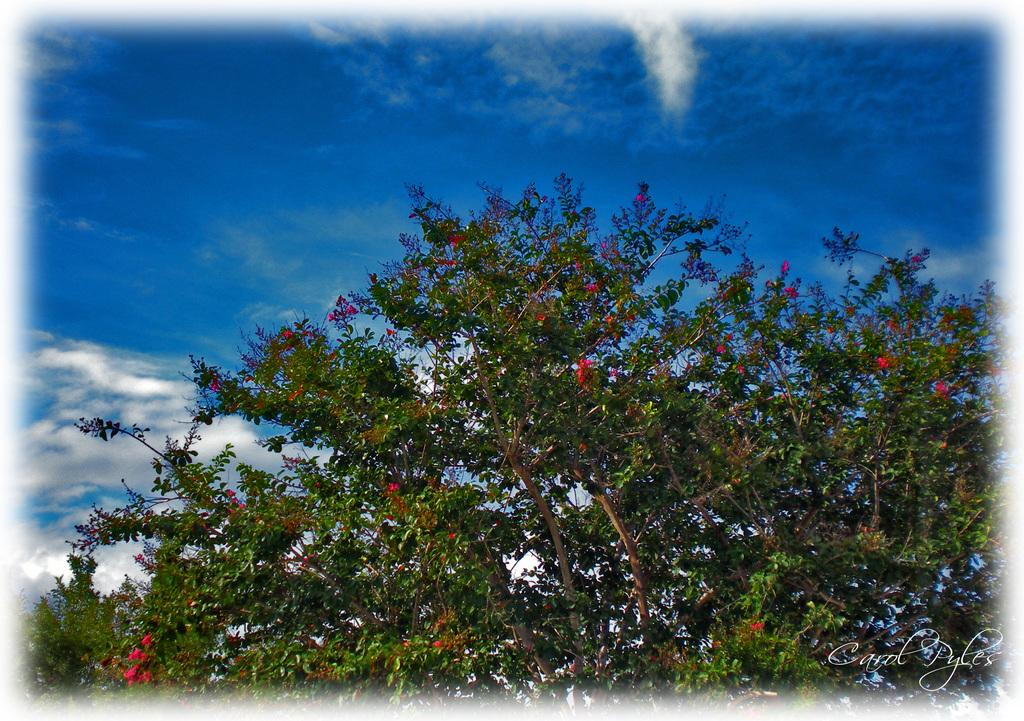Where was the image taken? The image was taken outside. What can be seen in the middle of the image? There is a tree in the middle of the image. What is visible at the top of the image? The sky is visible at the top of the image. What type of bait is being used to catch fish in the image? There is no bait or fishing activity present in the image. Can you see a chessboard or chess pieces in the image? There is no chessboard or chess pieces visible in the image. 